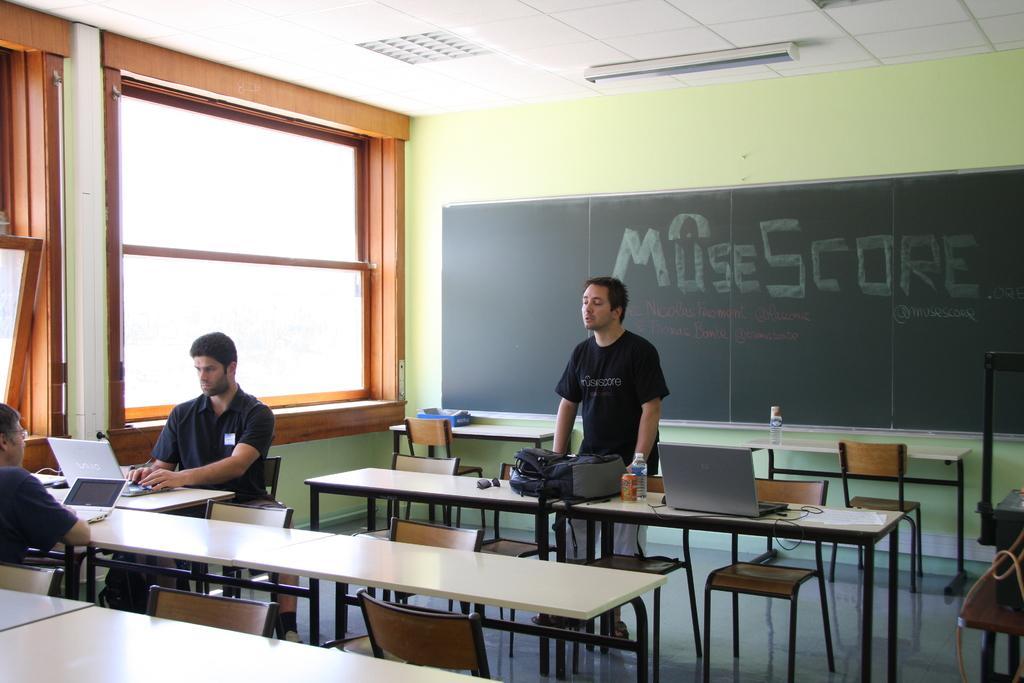Please provide a concise description of this image. The picture is taken in a room where only three people are present, in the middle of the picture one person is wearing a black t-shirt and standing in front of a table there is a bag,bottle and a can and laptop on it. There are chairs behind him there is a blackboard and some text written on it and at the left corner of the picture there are two people sitting in the chairs and using their laptops and beside them there is a big window is present. 